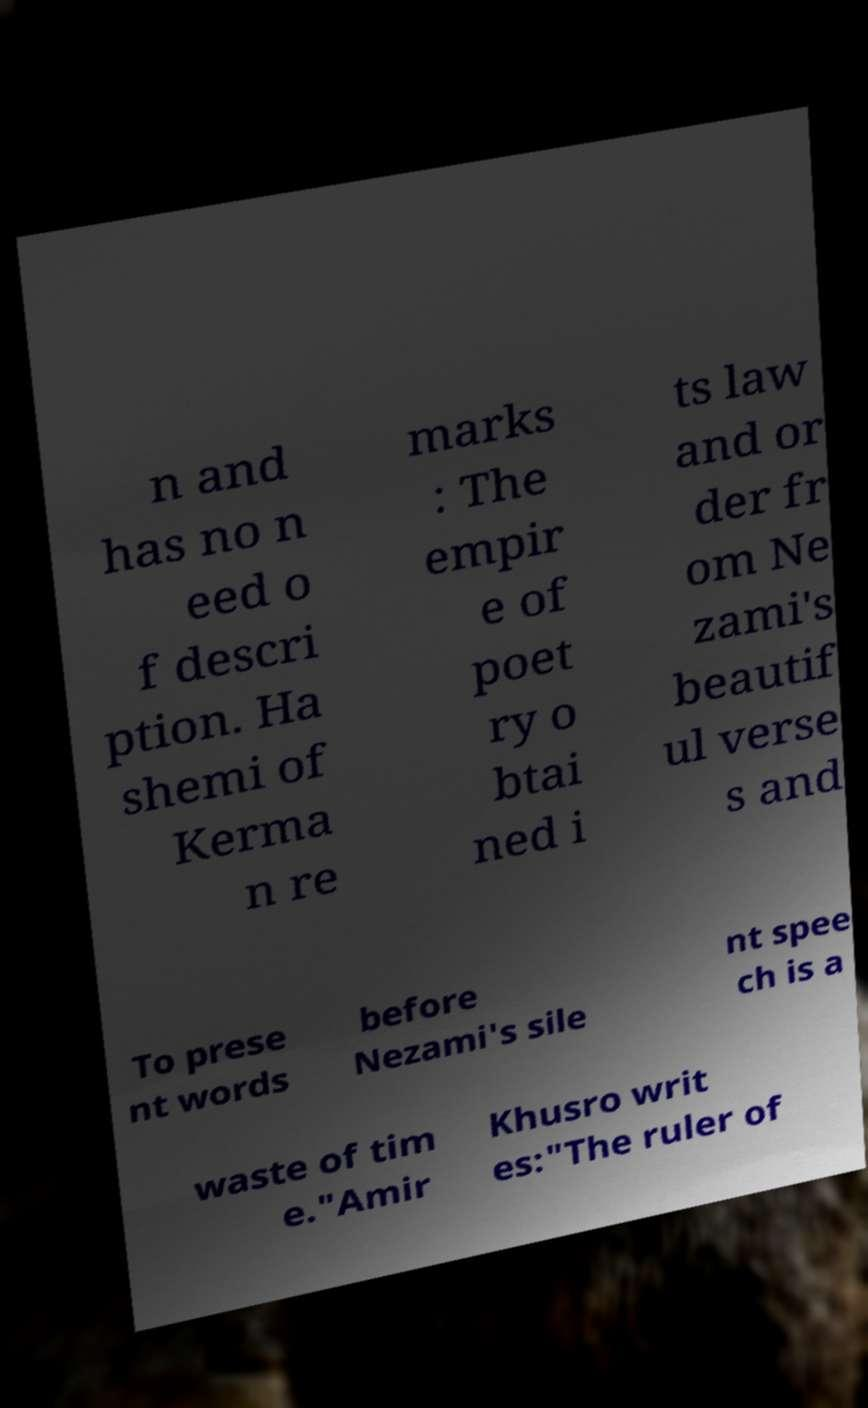For documentation purposes, I need the text within this image transcribed. Could you provide that? n and has no n eed o f descri ption. Ha shemi of Kerma n re marks : The empir e of poet ry o btai ned i ts law and or der fr om Ne zami's beautif ul verse s and To prese nt words before Nezami's sile nt spee ch is a waste of tim e."Amir Khusro writ es:"The ruler of 